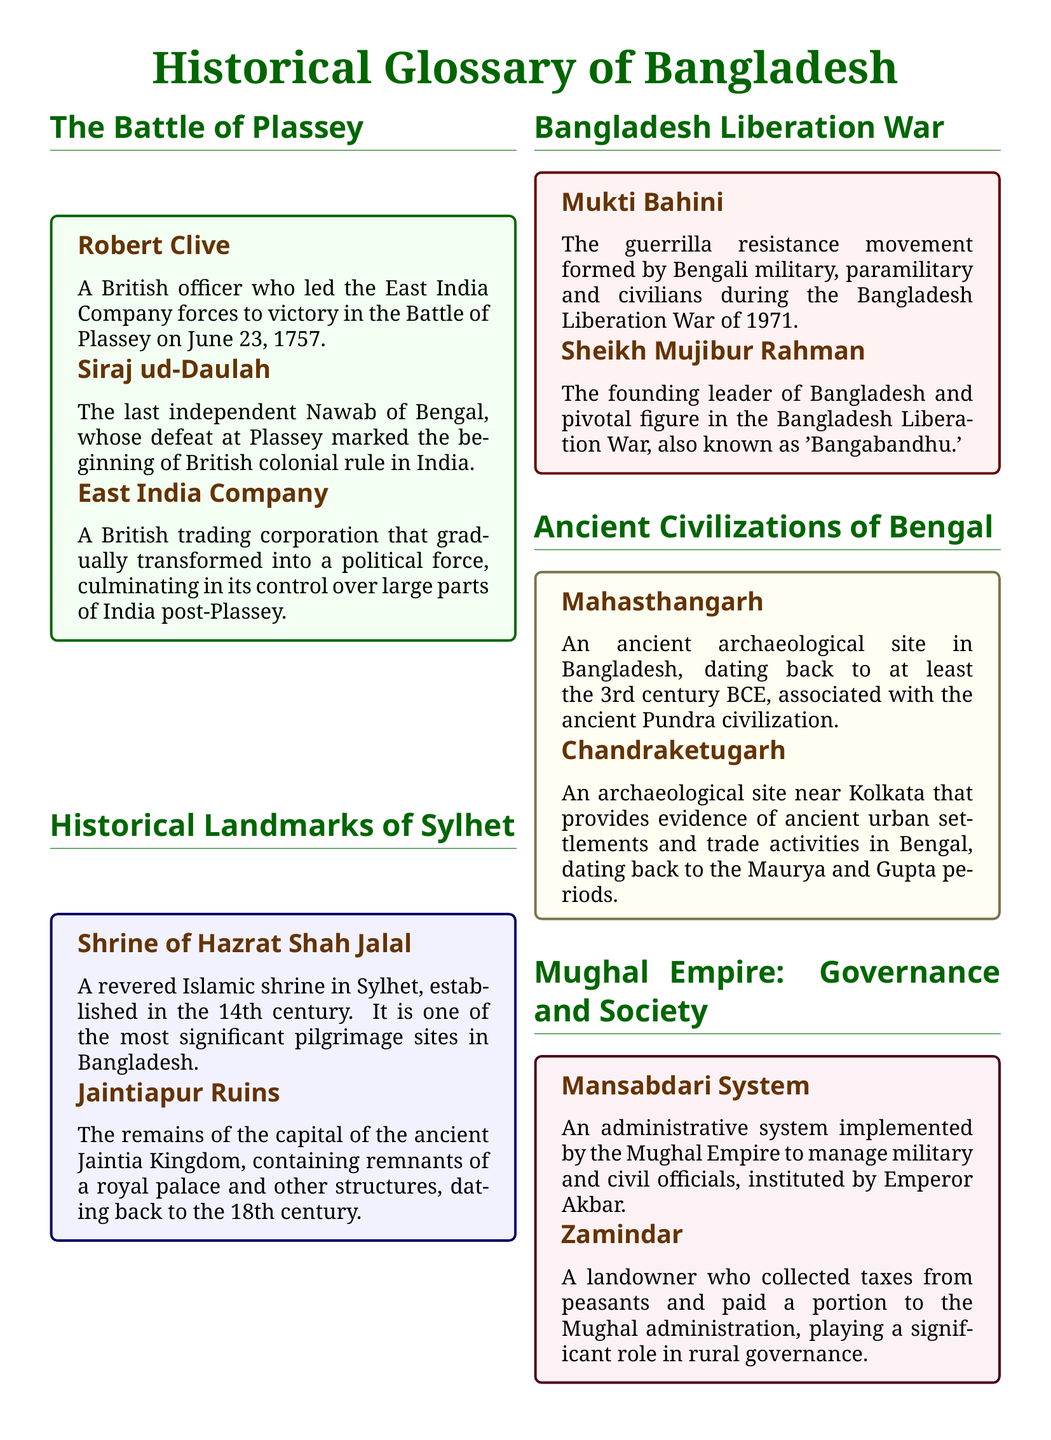What date did the Battle of Plassey occur? The document states that the Battle of Plassey took place on June 23, 1757.
Answer: June 23, 1757 Who led the East India Company forces in the Battle of Plassey? According to the glossary, Robert Clive was the British officer who led the East India Company forces.
Answer: Robert Clive What is the significance of Siraj ud-Daulah? The glossary describes Siraj ud-Daulah as the last independent Nawab of Bengal, marking a pivotal moment in Indian history.
Answer: Last independent Nawab of Bengal What is the name of the ancient archaeological site mentioned from the Pundra civilization? The document lists Mahasthangarh as the archaeological site associated with the ancient Pundra civilization.
Answer: Mahasthangarh What was the role of the Mukti Bahini during the liberation war? The glossary describes the Mukti Bahini as a guerrilla resistance movement formed during the Bangladesh Liberation War.
Answer: Guerrilla resistance movement Which administrative system was implemented by the Mughal Empire? The document states that the Mansabdari System was implemented by the Mughal Empire.
Answer: Mansabdari System Who is known as 'Bangabandhu'? The glossary refers to Sheikh Mujibur Rahman as 'Bangabandhu.'
Answer: Sheikh Mujibur Rahman What does the term Zamindar refer to? According to the glossary, the term Zamindar refers to a landowner who collected taxes.
Answer: Landowner 